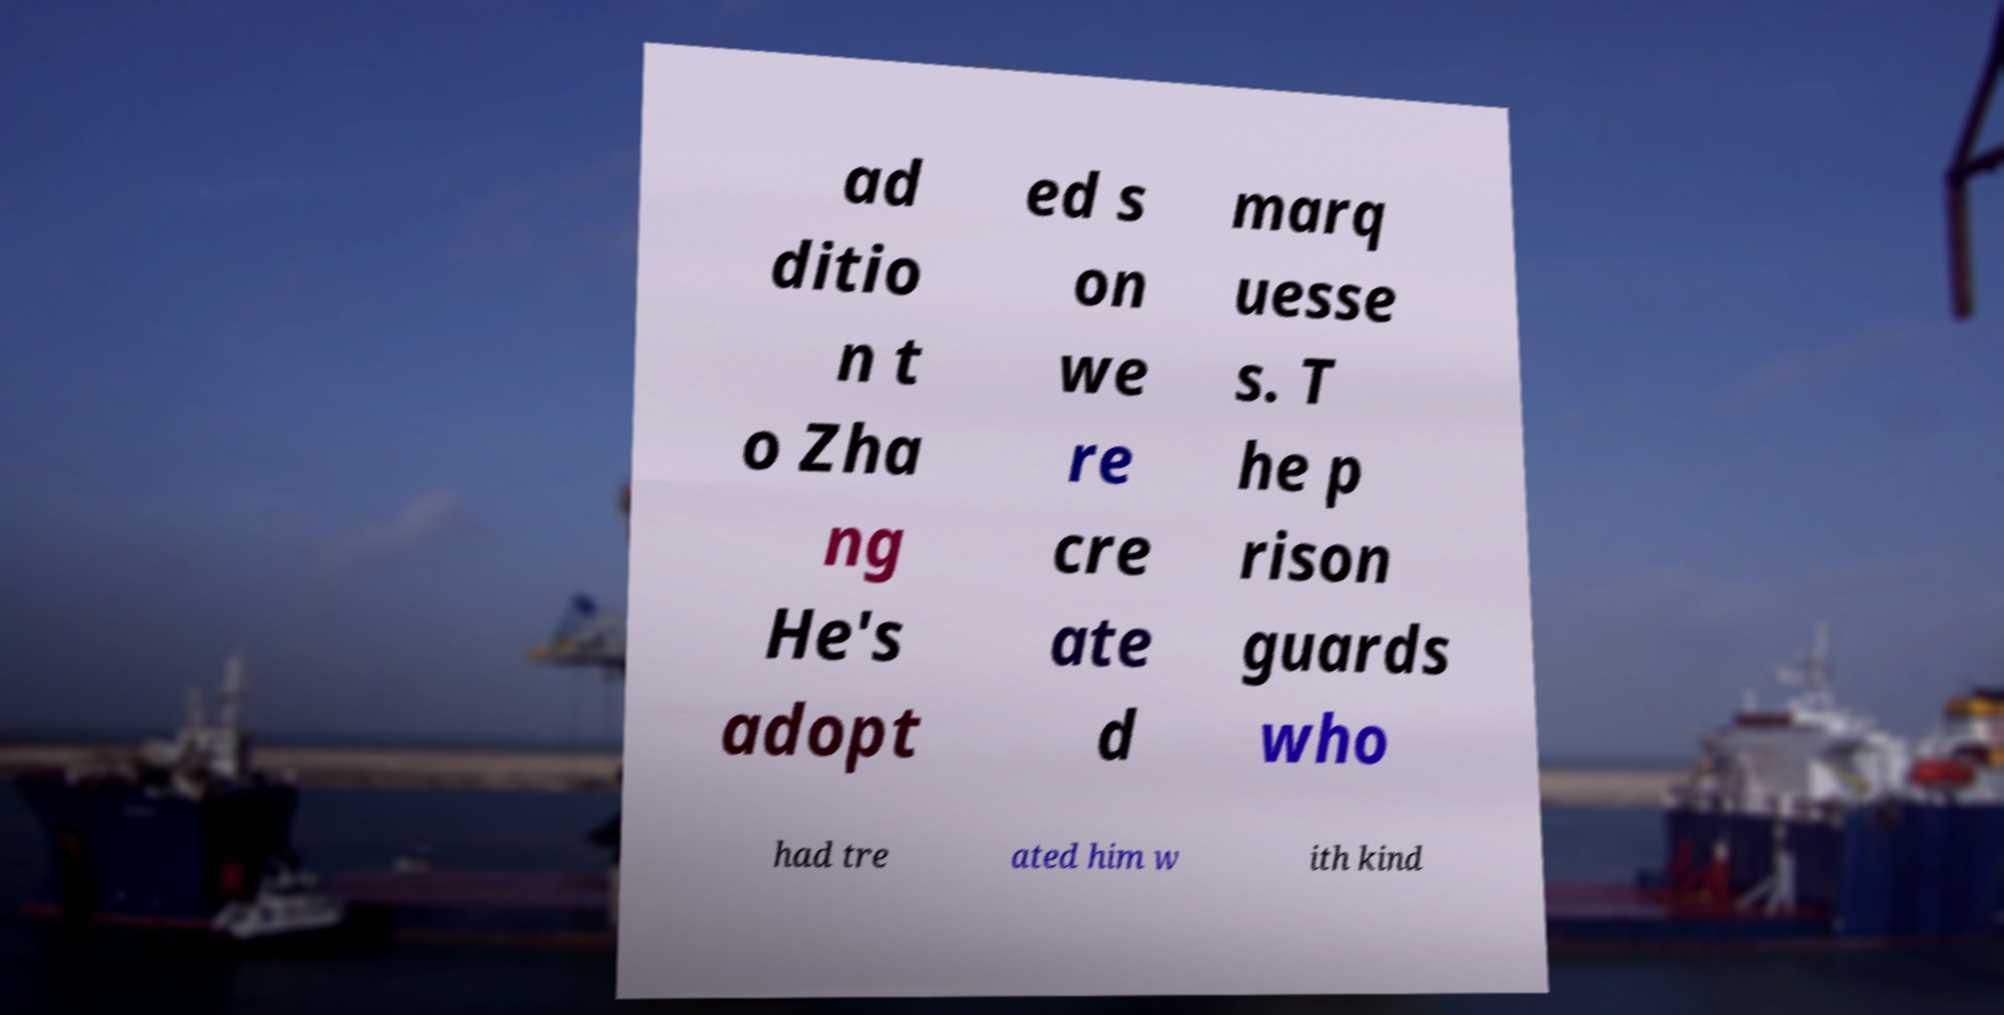What messages or text are displayed in this image? I need them in a readable, typed format. ad ditio n t o Zha ng He's adopt ed s on we re cre ate d marq uesse s. T he p rison guards who had tre ated him w ith kind 